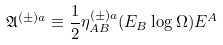<formula> <loc_0><loc_0><loc_500><loc_500>\mathfrak { A } ^ { ( \pm ) a } \equiv \frac { 1 } { 2 } \eta ^ { ( \pm ) a } _ { A B } ( E _ { B } \log \Omega ) E ^ { A }</formula> 